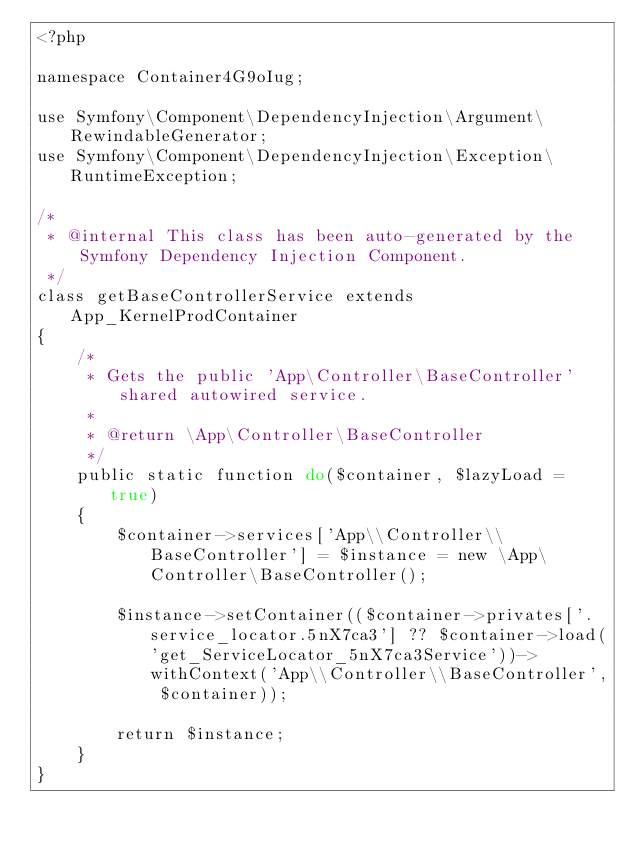<code> <loc_0><loc_0><loc_500><loc_500><_PHP_><?php

namespace Container4G9oIug;

use Symfony\Component\DependencyInjection\Argument\RewindableGenerator;
use Symfony\Component\DependencyInjection\Exception\RuntimeException;

/*
 * @internal This class has been auto-generated by the Symfony Dependency Injection Component.
 */
class getBaseControllerService extends App_KernelProdContainer
{
    /*
     * Gets the public 'App\Controller\BaseController' shared autowired service.
     *
     * @return \App\Controller\BaseController
     */
    public static function do($container, $lazyLoad = true)
    {
        $container->services['App\\Controller\\BaseController'] = $instance = new \App\Controller\BaseController();

        $instance->setContainer(($container->privates['.service_locator.5nX7ca3'] ?? $container->load('get_ServiceLocator_5nX7ca3Service'))->withContext('App\\Controller\\BaseController', $container));

        return $instance;
    }
}
</code> 